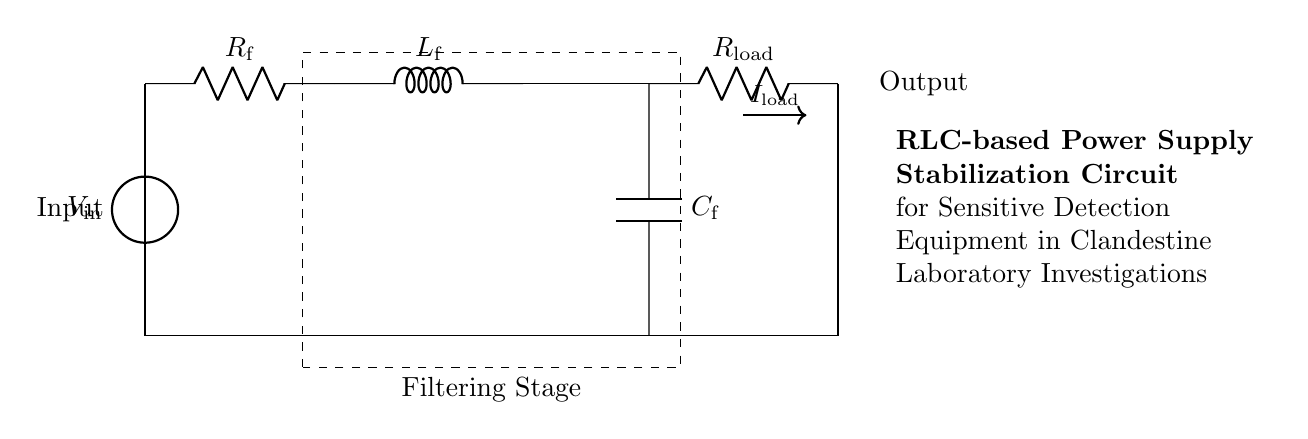What is the input voltage in this circuit? The input voltage is represented by the voltage source labeled V_in. This is the voltage supplied to the rest of the circuit, mentioned explicitly in the diagram.
Answer: V_in What component is used for filtering in this circuit? The filtering stage is indicated in the diagram by the dashed rectangle encompassing the resistor, inductor, and capacitor. These components work together to filter and stabilize the voltage supplied to the output.
Answer: Resistor, Inductor, Capacitor What type of load is this circuit designed to supply? The load connected in this circuit is labeled R_load, indicating that the circuit is providing power to a resistive load. This type of load would be typical for many electronic applications.
Answer: R_load What is the role of the inductor in this circuit? The inductor, labeled L_f, is used to store energy in a magnetic field when current flows through it. In combination with the resistor and capacitor, it helps enhance the stability of the power supply by smoothing out fluctuations in current and voltage.
Answer: Energy storage How does the circuit handle changes in load current? The presence of the resistor, inductor, and capacitor (RLC) together forms a filter that can respond to changes in load current (I_load). The inductor resists changes in current, while the capacitor can charge and discharge as needed, allowing the circuit to stabilize the output voltage even as the load varies.
Answer: Stabilizes output voltage What is the purpose of the capacitor in this circuit? The capacitor, labeled C_f, acts as a smoothing element in the power supply circuit. It stores charge and releases it when needed, thereby reducing voltage fluctuations and providing a more stable output to sensitive detection equipment.
Answer: Smoothing 